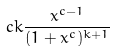<formula> <loc_0><loc_0><loc_500><loc_500>c k \frac { x ^ { c - 1 } } { ( 1 + x ^ { c } ) ^ { k + 1 } }</formula> 